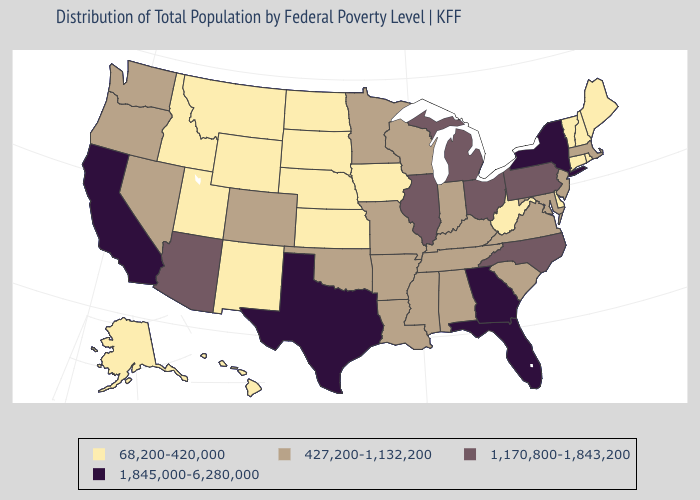Does Missouri have the highest value in the MidWest?
Quick response, please. No. Which states hav the highest value in the West?
Be succinct. California. Does Massachusetts have the highest value in the Northeast?
Be succinct. No. What is the highest value in the MidWest ?
Give a very brief answer. 1,170,800-1,843,200. What is the lowest value in the USA?
Be succinct. 68,200-420,000. What is the value of Iowa?
Concise answer only. 68,200-420,000. What is the value of Vermont?
Concise answer only. 68,200-420,000. Among the states that border Nevada , does California have the highest value?
Be succinct. Yes. Name the states that have a value in the range 1,845,000-6,280,000?
Give a very brief answer. California, Florida, Georgia, New York, Texas. What is the highest value in the USA?
Concise answer only. 1,845,000-6,280,000. Name the states that have a value in the range 1,845,000-6,280,000?
Be succinct. California, Florida, Georgia, New York, Texas. Which states have the highest value in the USA?
Answer briefly. California, Florida, Georgia, New York, Texas. What is the value of Tennessee?
Be succinct. 427,200-1,132,200. Name the states that have a value in the range 68,200-420,000?
Answer briefly. Alaska, Connecticut, Delaware, Hawaii, Idaho, Iowa, Kansas, Maine, Montana, Nebraska, New Hampshire, New Mexico, North Dakota, Rhode Island, South Dakota, Utah, Vermont, West Virginia, Wyoming. 